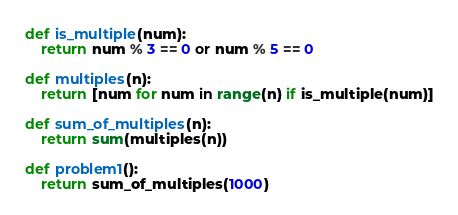Convert code to text. <code><loc_0><loc_0><loc_500><loc_500><_Python_>def is_multiple(num):
    return num % 3 == 0 or num % 5 == 0

def multiples(n):
    return [num for num in range(n) if is_multiple(num)]

def sum_of_multiples(n):
    return sum(multiples(n))

def problem1():
    return sum_of_multiples(1000)    </code> 